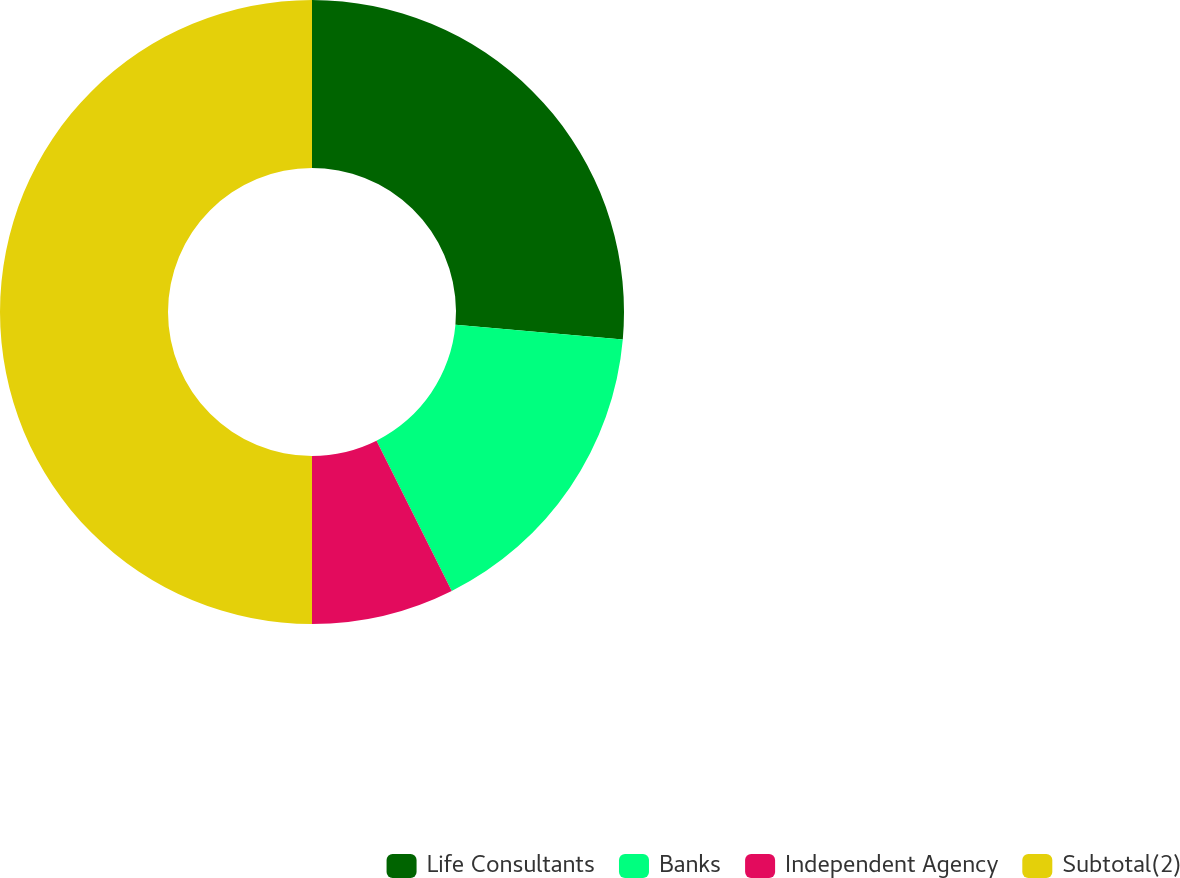Convert chart. <chart><loc_0><loc_0><loc_500><loc_500><pie_chart><fcel>Life Consultants<fcel>Banks<fcel>Independent Agency<fcel>Subtotal(2)<nl><fcel>26.4%<fcel>16.21%<fcel>7.39%<fcel>50.0%<nl></chart> 